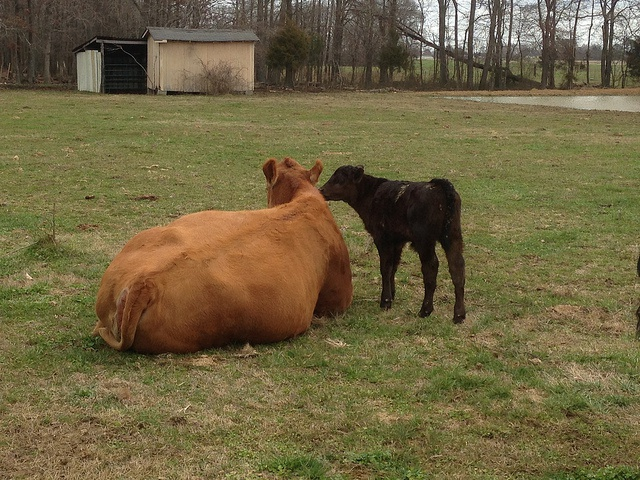Describe the objects in this image and their specific colors. I can see cow in black, brown, maroon, and tan tones and cow in black, darkgreen, and gray tones in this image. 